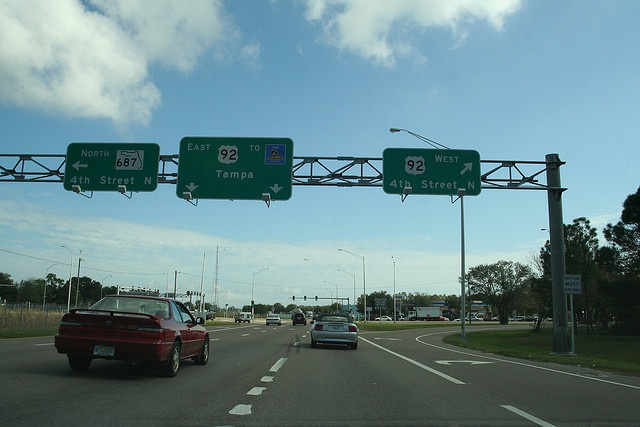Describe the objects in this image and their specific colors. I can see car in lightgray, black, gray, maroon, and teal tones, car in lightgray, black, teal, and darkgreen tones, truck in lightgray, gray, black, and teal tones, truck in lightgray, black, gray, darkgray, and darkgreen tones, and truck in lightgray, black, gray, and darkgray tones in this image. 